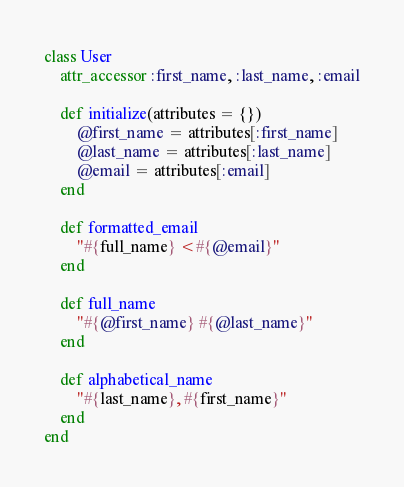<code> <loc_0><loc_0><loc_500><loc_500><_Ruby_>class User
	attr_accessor :first_name, :last_name, :email

	def initialize(attributes = {})
		@first_name = attributes[:first_name]
		@last_name = attributes[:last_name]
		@email = attributes[:email]
	end

	def formatted_email
		"#{full_name} <#{@email}"
	end

	def full_name
		"#{@first_name} #{@last_name}"
	end

	def alphabetical_name
		"#{last_name}, #{first_name}"
	end
end</code> 